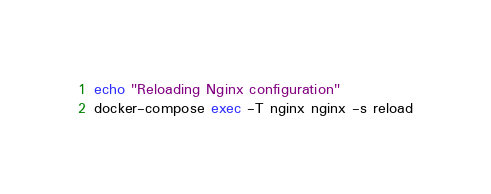<code> <loc_0><loc_0><loc_500><loc_500><_Bash_>echo "Reloading Nginx configuration"
docker-compose exec -T nginx nginx -s reload
</code> 